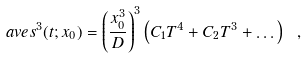Convert formula to latex. <formula><loc_0><loc_0><loc_500><loc_500>\ a v e { s ^ { 3 } } ( t ; x _ { 0 } ) = \left ( \frac { x _ { 0 } ^ { 3 } } { D } \right ) ^ { 3 } \left ( C _ { 1 } T ^ { 4 } + C _ { 2 } T ^ { 3 } + \dots \right ) \ ,</formula> 